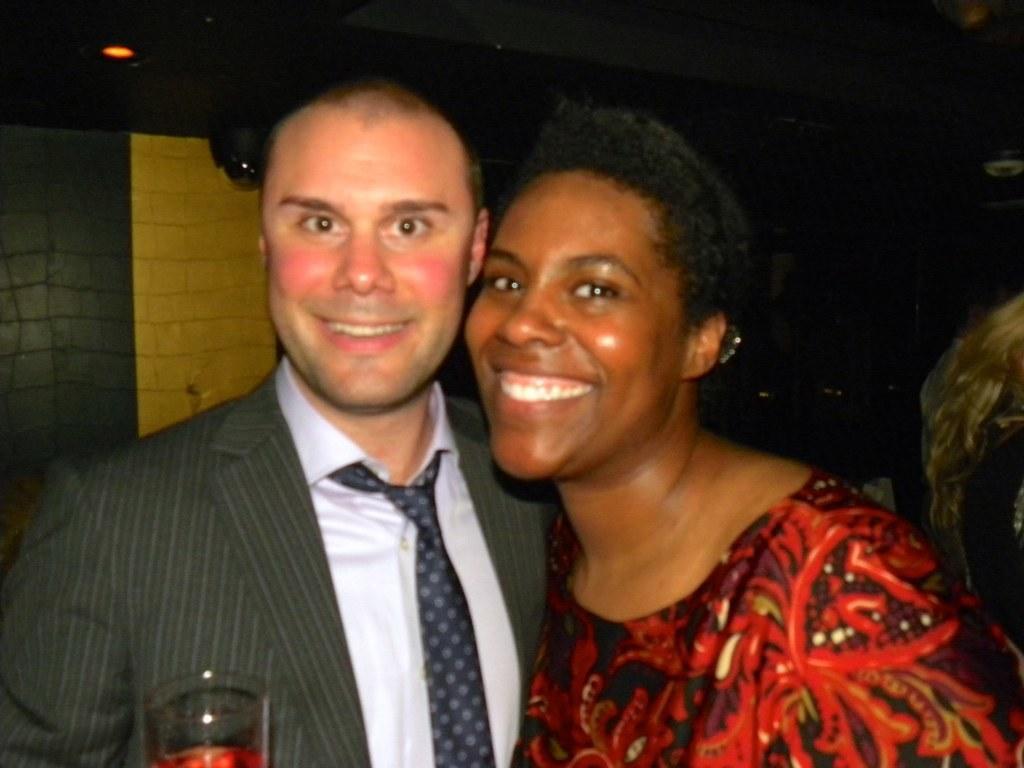In one or two sentences, can you explain what this image depicts? In this picture we can see a man and a woman, they are smiling, here we can see a glass, at the back of them we can see a light and some objects and in the background we can see it is dark. 